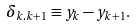Convert formula to latex. <formula><loc_0><loc_0><loc_500><loc_500>\delta _ { k , k + 1 } \equiv y _ { k } - y _ { k + 1 } .</formula> 